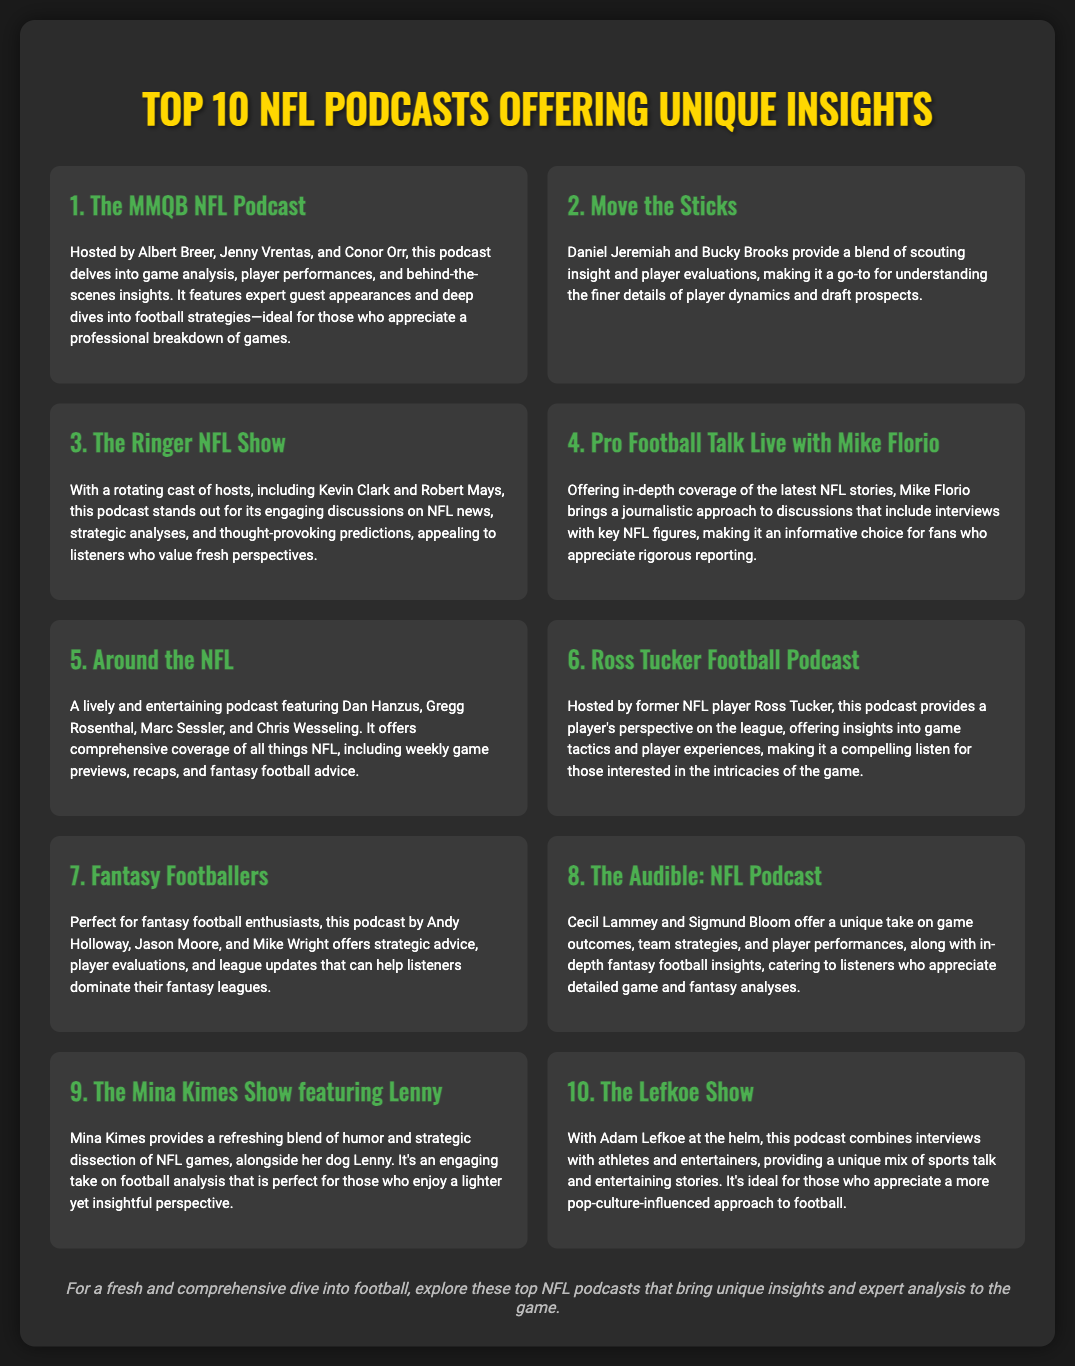What is the title of the document? The title of the document is presented as the main heading in the center, which is "Top 10 NFL Podcasts Offering Unique Insights".
Answer: Top 10 NFL Podcasts Offering Unique Insights Who hosts "The MMQB NFL Podcast"? The names of the hosts for "The MMQB NFL Podcast" are mentioned in the description, which includes Albert Breer, Jenny Vrentas, and Conor Orr.
Answer: Albert Breer, Jenny Vrentas, and Conor Orr What is the primary focus of the "Fantasy Footballers" podcast? The description specifies that "Fantasy Footballers" focuses on strategic advice, player evaluations, and league updates for fantasy football enthusiasts.
Answer: Fantasy football strategic advice Which podcast features a humorous and strategic analysis of NFL games? The description indicates that "The Mina Kimes Show featuring Lenny" provides a blend of humor and strategic dissection of NFL games.
Answer: The Mina Kimes Show featuring Lenny How many podcasts are listed in the document? The total number of podcasts mentioned in the document is shown by the heading and the content, which states "Top 10 NFL Podcasts".
Answer: 10 